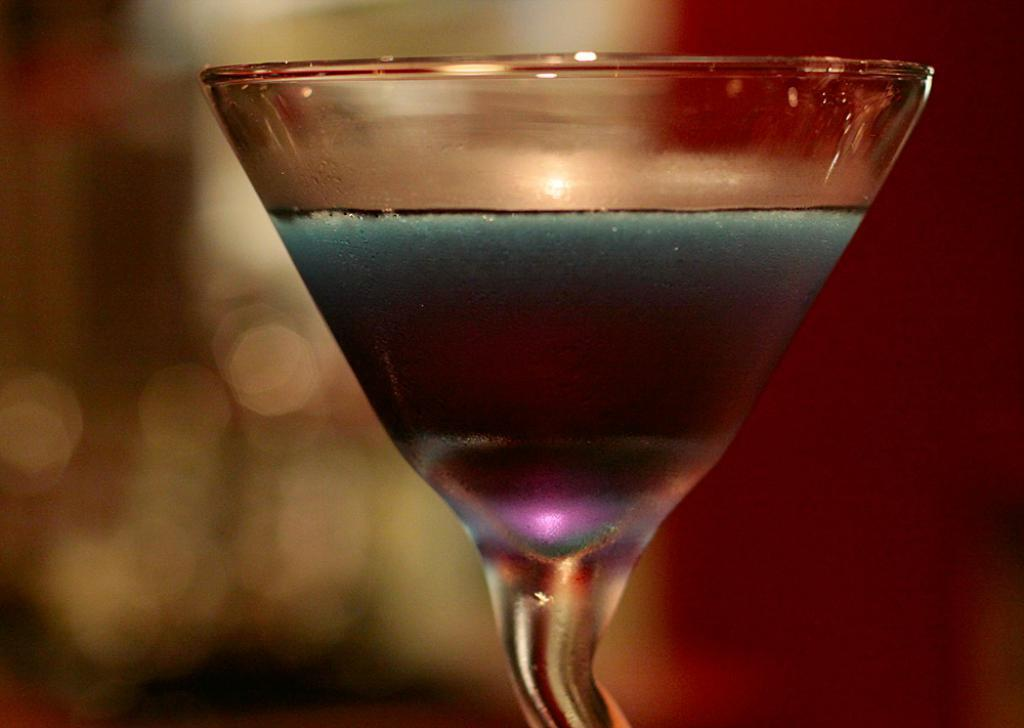What object is visible in the image? There is a glass in the image. Can you describe the background of the image? The background of the image is blurred. What type of sign can be seen in the image? There is no sign present in the image; it only features a glass and a blurred background. How many boats are visible in the image? There are no boats present in the image. 